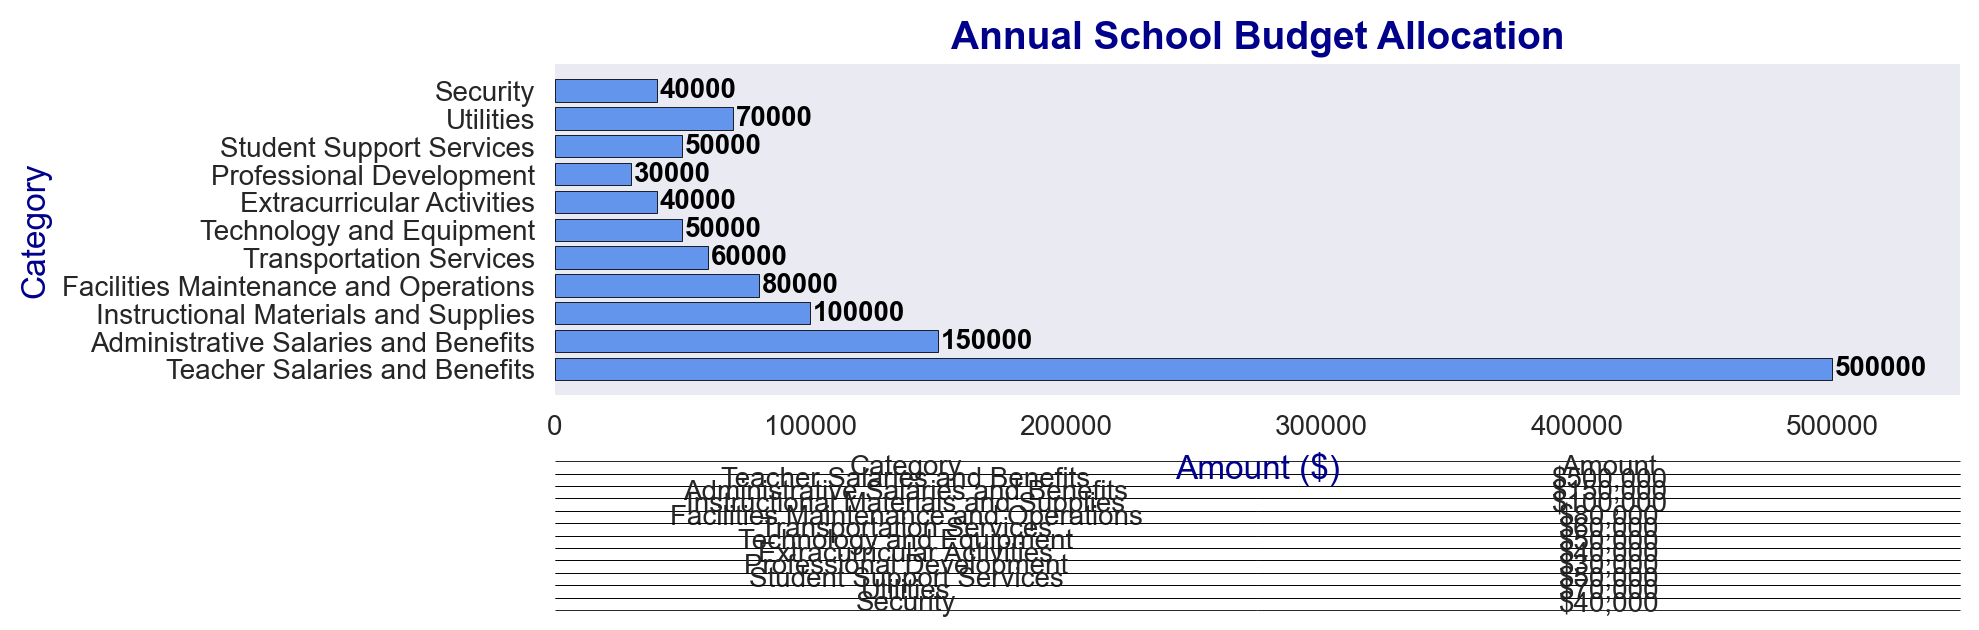What is the category with the highest allocation? By looking at the length of the bars, the "Teacher Salaries and Benefits" category has the longest bar, indicating the largest allocation amount.
Answer: Teacher Salaries and Benefits What is the total amount allocated to extracurricular activities and student support services? The amounts allocated to "Extracurricular Activities" and "Student Support Services" are $40,000 and $50,000, respectively. Summing them up, 40,000 + 50,000 = 90,000.
Answer: $90,000 Which categories have an allocation amount of $50,000? There are two categories with bars labeled $50,000: "Technology and Equipment" and "Student Support Services".
Answer: Technology and Equipment, Student Support Services How much more is allocated to teacher salaries and benefits compared to administrative salaries and benefits? The allocation for "Teacher Salaries and Benefits" is $500,000, and for "Administrative Salaries and Benefits" it is $150,000. The difference is 500,000 - 150,000 = 350,000.
Answer: $350,000 Which has a higher budget allocation: utilities or transportation services? By comparing the bars, "Utilities" has an allocation of $70,000, while "Transportation Services" has $60,000. Therefore, "Utilities" has a higher allocation.
Answer: Utilities What is the total amount allocated to all categories combined? Summing up the amounts: 500,000 + 150,000 + 100,000 + 80,000 + 60,000 + 50,000 + 40,000 + 30,000 + 50,000 + 70,000 + 40,000 = 1,170,000.
Answer: $1,170,000 What percentage of the total budget is allocated to teacher salaries and benefits? The total budget is $1,170,000. The allocation for "Teacher Salaries and Benefits" is $500,000. The percentage is (500,000 / 1,170,000) * 100 ≈ 42.74%.
Answer: 42.74% Compare the allocations for professional development and security. Which one is higher and by how much? "Professional Development" has an allocation of $30,000, and "Security" has $40,000. Security has a higher allocation, and the difference is 40,000 - 30,000 = 10,000.
Answer: Security by $10,000 